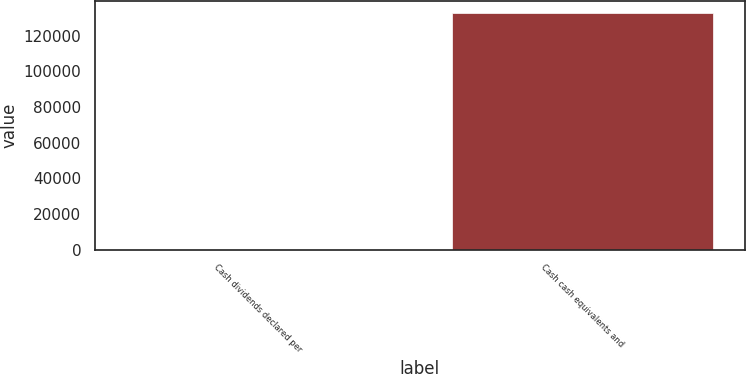Convert chart to OTSL. <chart><loc_0><loc_0><loc_500><loc_500><bar_chart><fcel>Cash dividends declared per<fcel>Cash cash equivalents and<nl><fcel>1.56<fcel>132981<nl></chart> 